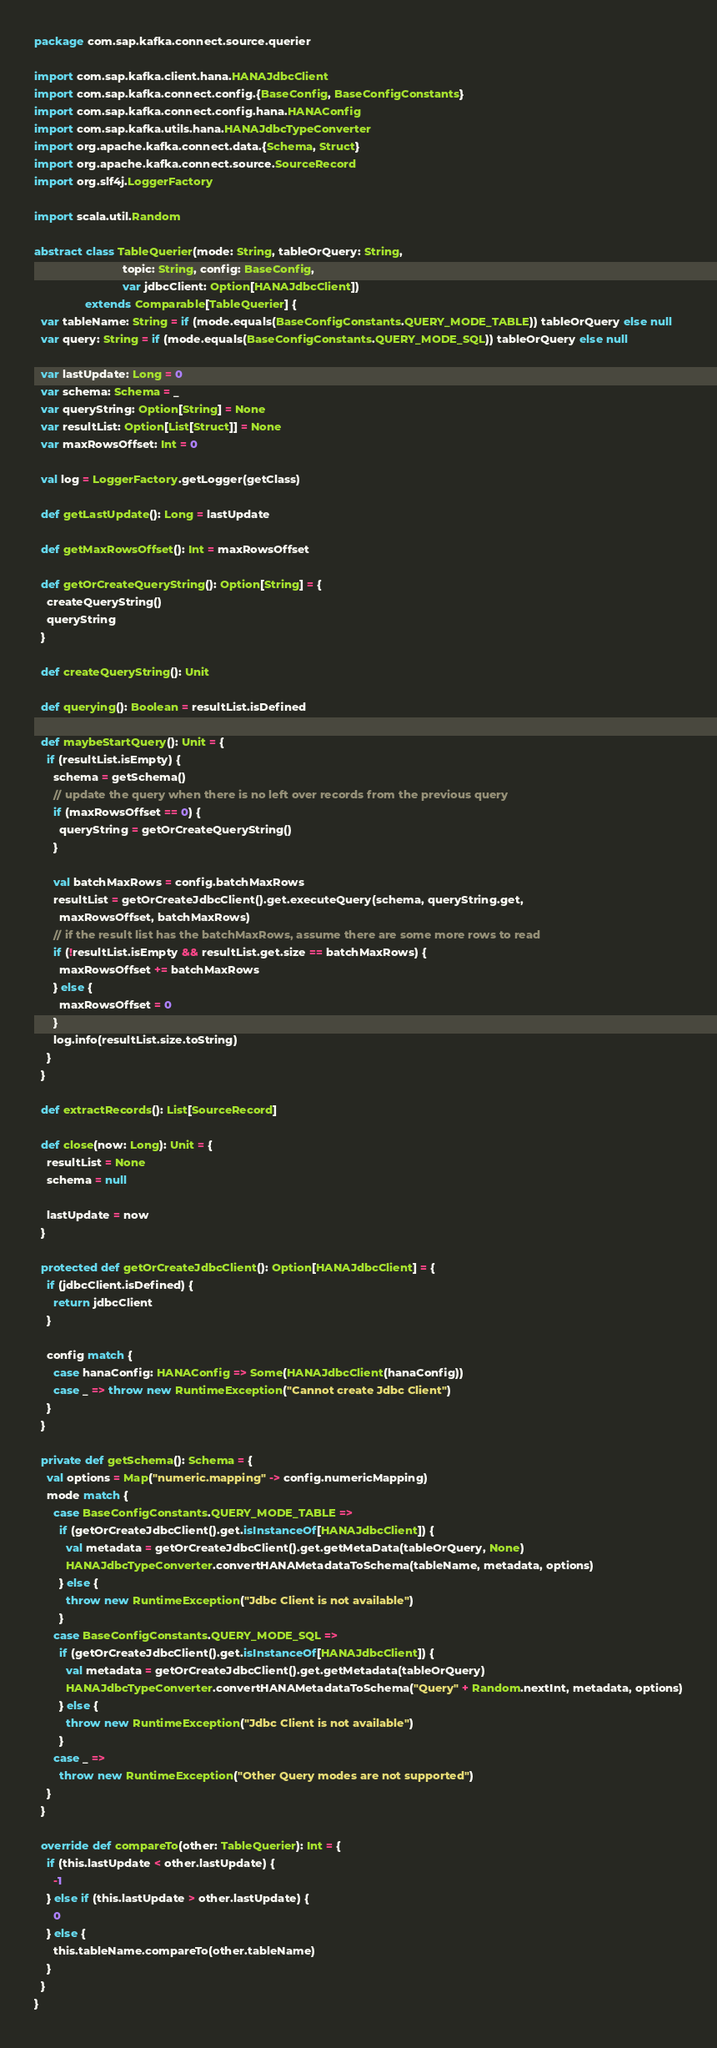<code> <loc_0><loc_0><loc_500><loc_500><_Scala_>package com.sap.kafka.connect.source.querier

import com.sap.kafka.client.hana.HANAJdbcClient
import com.sap.kafka.connect.config.{BaseConfig, BaseConfigConstants}
import com.sap.kafka.connect.config.hana.HANAConfig
import com.sap.kafka.utils.hana.HANAJdbcTypeConverter
import org.apache.kafka.connect.data.{Schema, Struct}
import org.apache.kafka.connect.source.SourceRecord
import org.slf4j.LoggerFactory

import scala.util.Random

abstract class TableQuerier(mode: String, tableOrQuery: String,
                            topic: String, config: BaseConfig,
                            var jdbcClient: Option[HANAJdbcClient])
                extends Comparable[TableQuerier] {
  var tableName: String = if (mode.equals(BaseConfigConstants.QUERY_MODE_TABLE)) tableOrQuery else null
  var query: String = if (mode.equals(BaseConfigConstants.QUERY_MODE_SQL)) tableOrQuery else null

  var lastUpdate: Long = 0
  var schema: Schema = _
  var queryString: Option[String] = None
  var resultList: Option[List[Struct]] = None
  var maxRowsOffset: Int = 0

  val log = LoggerFactory.getLogger(getClass)

  def getLastUpdate(): Long = lastUpdate

  def getMaxRowsOffset(): Int = maxRowsOffset

  def getOrCreateQueryString(): Option[String] = {
    createQueryString()
    queryString
  }

  def createQueryString(): Unit

  def querying(): Boolean = resultList.isDefined

  def maybeStartQuery(): Unit = {
    if (resultList.isEmpty) {
      schema = getSchema()
      // update the query when there is no left over records from the previous query
      if (maxRowsOffset == 0) {
        queryString = getOrCreateQueryString()
      }

      val batchMaxRows = config.batchMaxRows
      resultList = getOrCreateJdbcClient().get.executeQuery(schema, queryString.get,
        maxRowsOffset, batchMaxRows)
      // if the result list has the batchMaxRows, assume there are some more rows to read
      if (!resultList.isEmpty && resultList.get.size == batchMaxRows) {
        maxRowsOffset += batchMaxRows
      } else {
        maxRowsOffset = 0
      }
      log.info(resultList.size.toString)
    }
  }

  def extractRecords(): List[SourceRecord]

  def close(now: Long): Unit = {
    resultList = None
    schema = null

    lastUpdate = now
  }

  protected def getOrCreateJdbcClient(): Option[HANAJdbcClient] = {
    if (jdbcClient.isDefined) {
      return jdbcClient
    }

    config match {
      case hanaConfig: HANAConfig => Some(HANAJdbcClient(hanaConfig))
      case _ => throw new RuntimeException("Cannot create Jdbc Client")
    }
  }

  private def getSchema(): Schema = {
    val options = Map("numeric.mapping" -> config.numericMapping)
    mode match {
      case BaseConfigConstants.QUERY_MODE_TABLE =>
        if (getOrCreateJdbcClient().get.isInstanceOf[HANAJdbcClient]) {
          val metadata = getOrCreateJdbcClient().get.getMetaData(tableOrQuery, None)
          HANAJdbcTypeConverter.convertHANAMetadataToSchema(tableName, metadata, options)
        } else {
          throw new RuntimeException("Jdbc Client is not available")
        }
      case BaseConfigConstants.QUERY_MODE_SQL =>
        if (getOrCreateJdbcClient().get.isInstanceOf[HANAJdbcClient]) {
          val metadata = getOrCreateJdbcClient().get.getMetadata(tableOrQuery)
          HANAJdbcTypeConverter.convertHANAMetadataToSchema("Query" + Random.nextInt, metadata, options)
        } else {
          throw new RuntimeException("Jdbc Client is not available")
        }
      case _ =>
        throw new RuntimeException("Other Query modes are not supported")
    }
  }

  override def compareTo(other: TableQuerier): Int = {
    if (this.lastUpdate < other.lastUpdate) {
      -1
    } else if (this.lastUpdate > other.lastUpdate) {
      0
    } else {
      this.tableName.compareTo(other.tableName)
    }
  }
}
</code> 